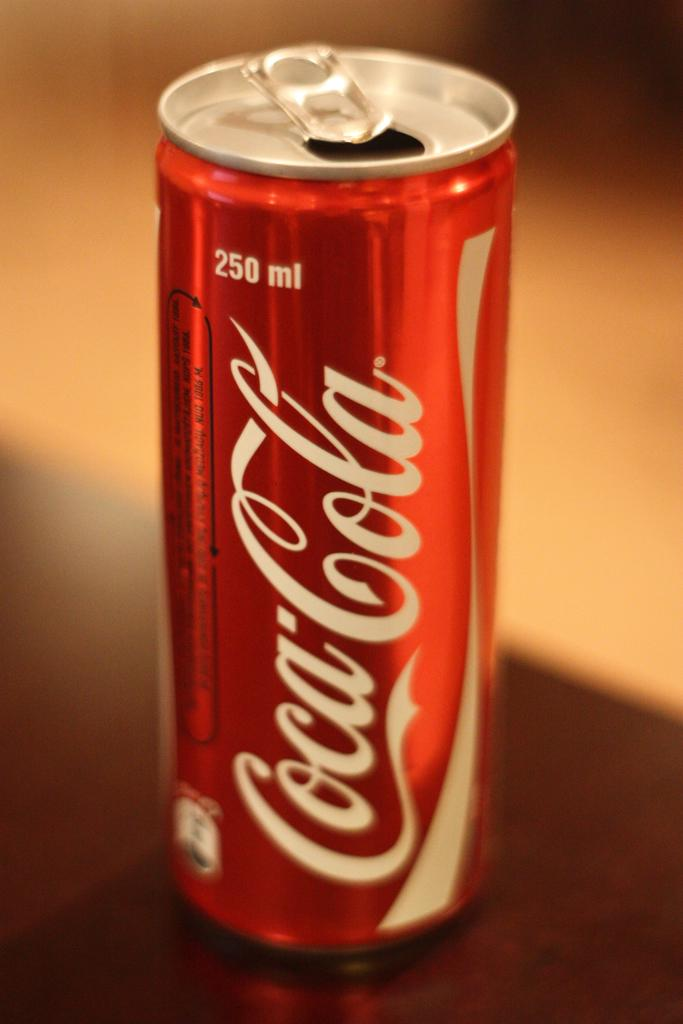<image>
Describe the image concisely. A 250 ml Coca Cola can sitting on a table. 